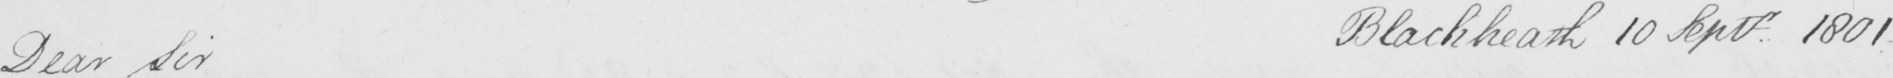Can you tell me what this handwritten text says? Dear Sir Blackheath 10 Septr . 1801 _ 